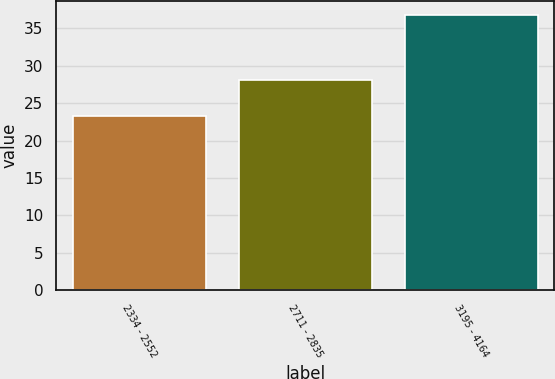<chart> <loc_0><loc_0><loc_500><loc_500><bar_chart><fcel>2334 - 2552<fcel>2711 - 2835<fcel>3195 - 4164<nl><fcel>23.34<fcel>28.12<fcel>36.84<nl></chart> 